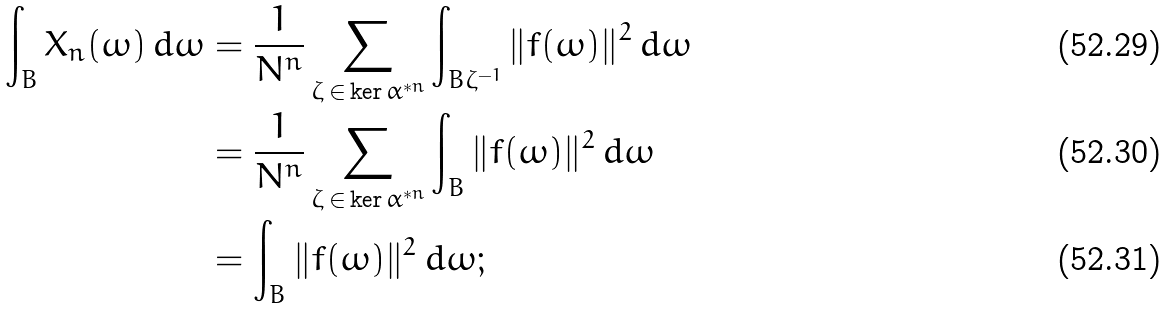Convert formula to latex. <formula><loc_0><loc_0><loc_500><loc_500>\int _ { B } X _ { n } ( \omega ) \, d \omega & = \frac { 1 } { N ^ { n } } \sum _ { \zeta \, \in \, \ker \alpha ^ { * n } } \int _ { B \zeta ^ { - 1 } } \| f ( \omega ) \| ^ { 2 } \, d \omega \\ & = \frac { 1 } { N ^ { n } } \sum _ { \zeta \, \in \, \ker \alpha ^ { * n } } \int _ { B } \| f ( \omega ) \| ^ { 2 } \, d \omega \\ & = \int _ { B } \| f ( \omega ) \| ^ { 2 } \, d \omega ;</formula> 